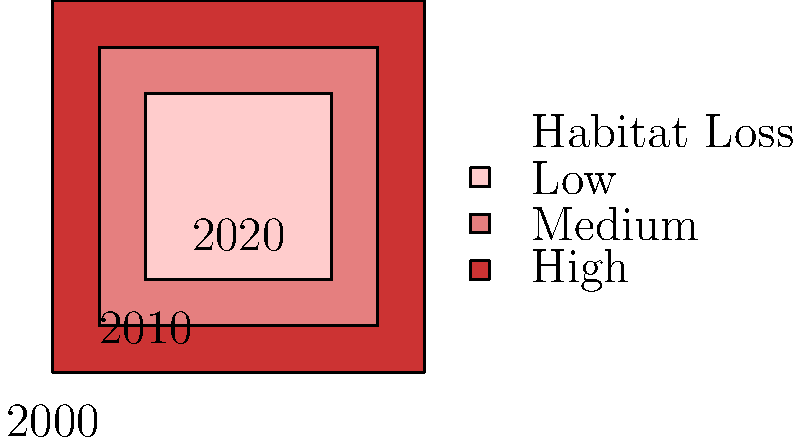Based on the color-coded map showing habitat loss trends for endemic Mexican birds from 2000 to 2020, what is the most concerning observation regarding conservation efforts? To answer this question, we need to analyze the color-coded map and interpret its meaning in the context of habitat loss for endemic Mexican birds:

1. The map shows three nested squares, each representing a different time period:
   - Outer square: 2000
   - Middle square: 2010
   - Inner square: 2020

2. The color legend indicates:
   - Red: High habitat loss
   - Pink: Medium habitat loss
   - Light pink: Low habitat loss

3. Analyzing the map from outer to inner:
   - 2000 (outer square): Dark red, indicating high habitat loss
   - 2010 (middle square): Medium pink, showing a decrease in habitat loss
   - 2020 (inner square): Light pink, suggesting further reduction in habitat loss

4. The trend shows an improvement in habitat conservation over time, with habitat loss decreasing from 2000 to 2020.

5. However, the most concerning observation is that despite the improvement, habitat loss is still occurring in 2020, albeit at a lower rate.

6. From a conservation perspective, the goal would be to completely halt habitat loss, which has not been achieved by 2020.

Therefore, the most concerning observation is that habitat loss, although reduced, is still ongoing in 2020 for endemic Mexican birds.
Answer: Habitat loss continues in 2020, despite reduction. 